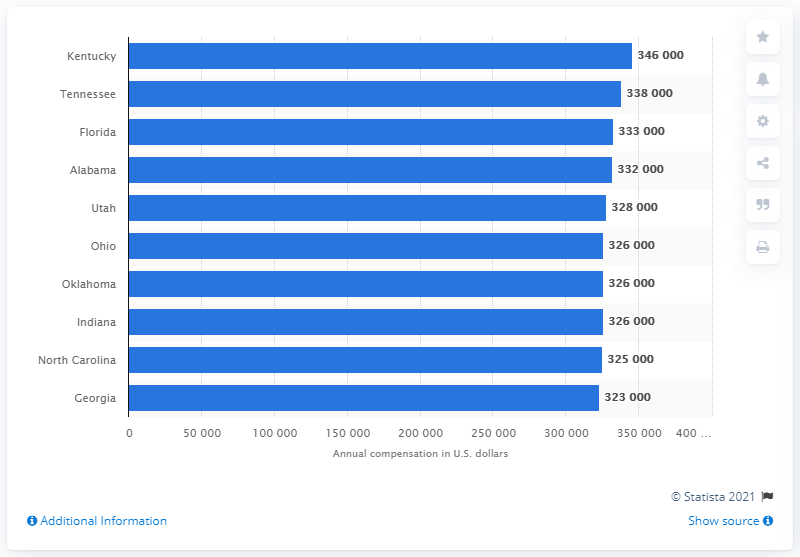Mention a couple of crucial points in this snapshot. Kentucky is the top earning state for physicians in the United States. 